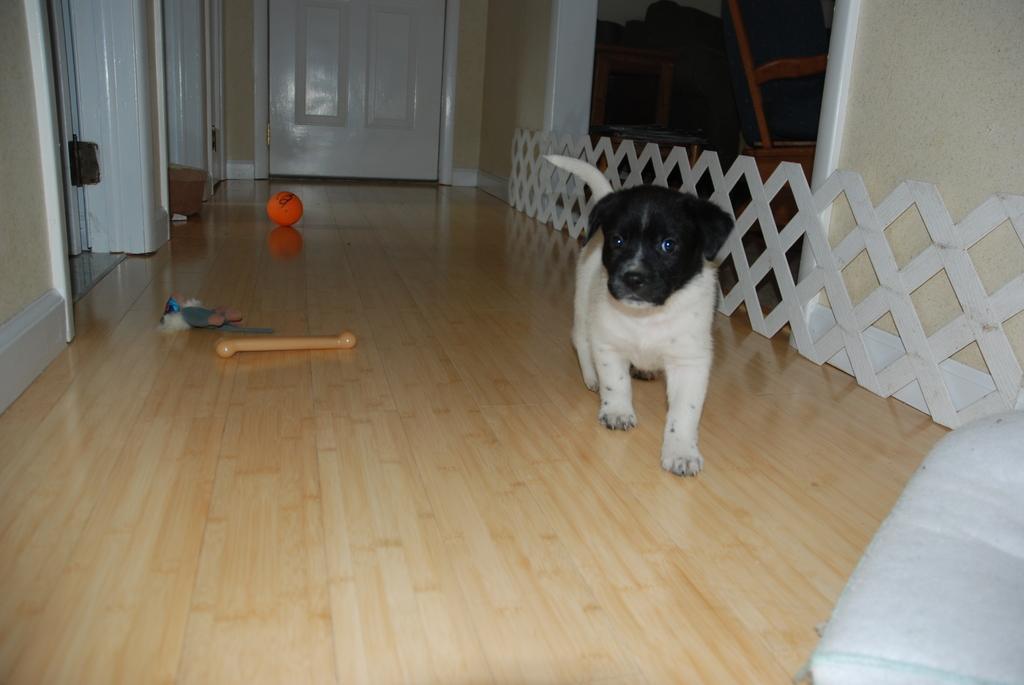In one or two sentences, can you explain what this image depicts? In this image there is a puppy. There is a ball. There is a door at the background of the image. At the bottom of the image there is a wooden flooring. 